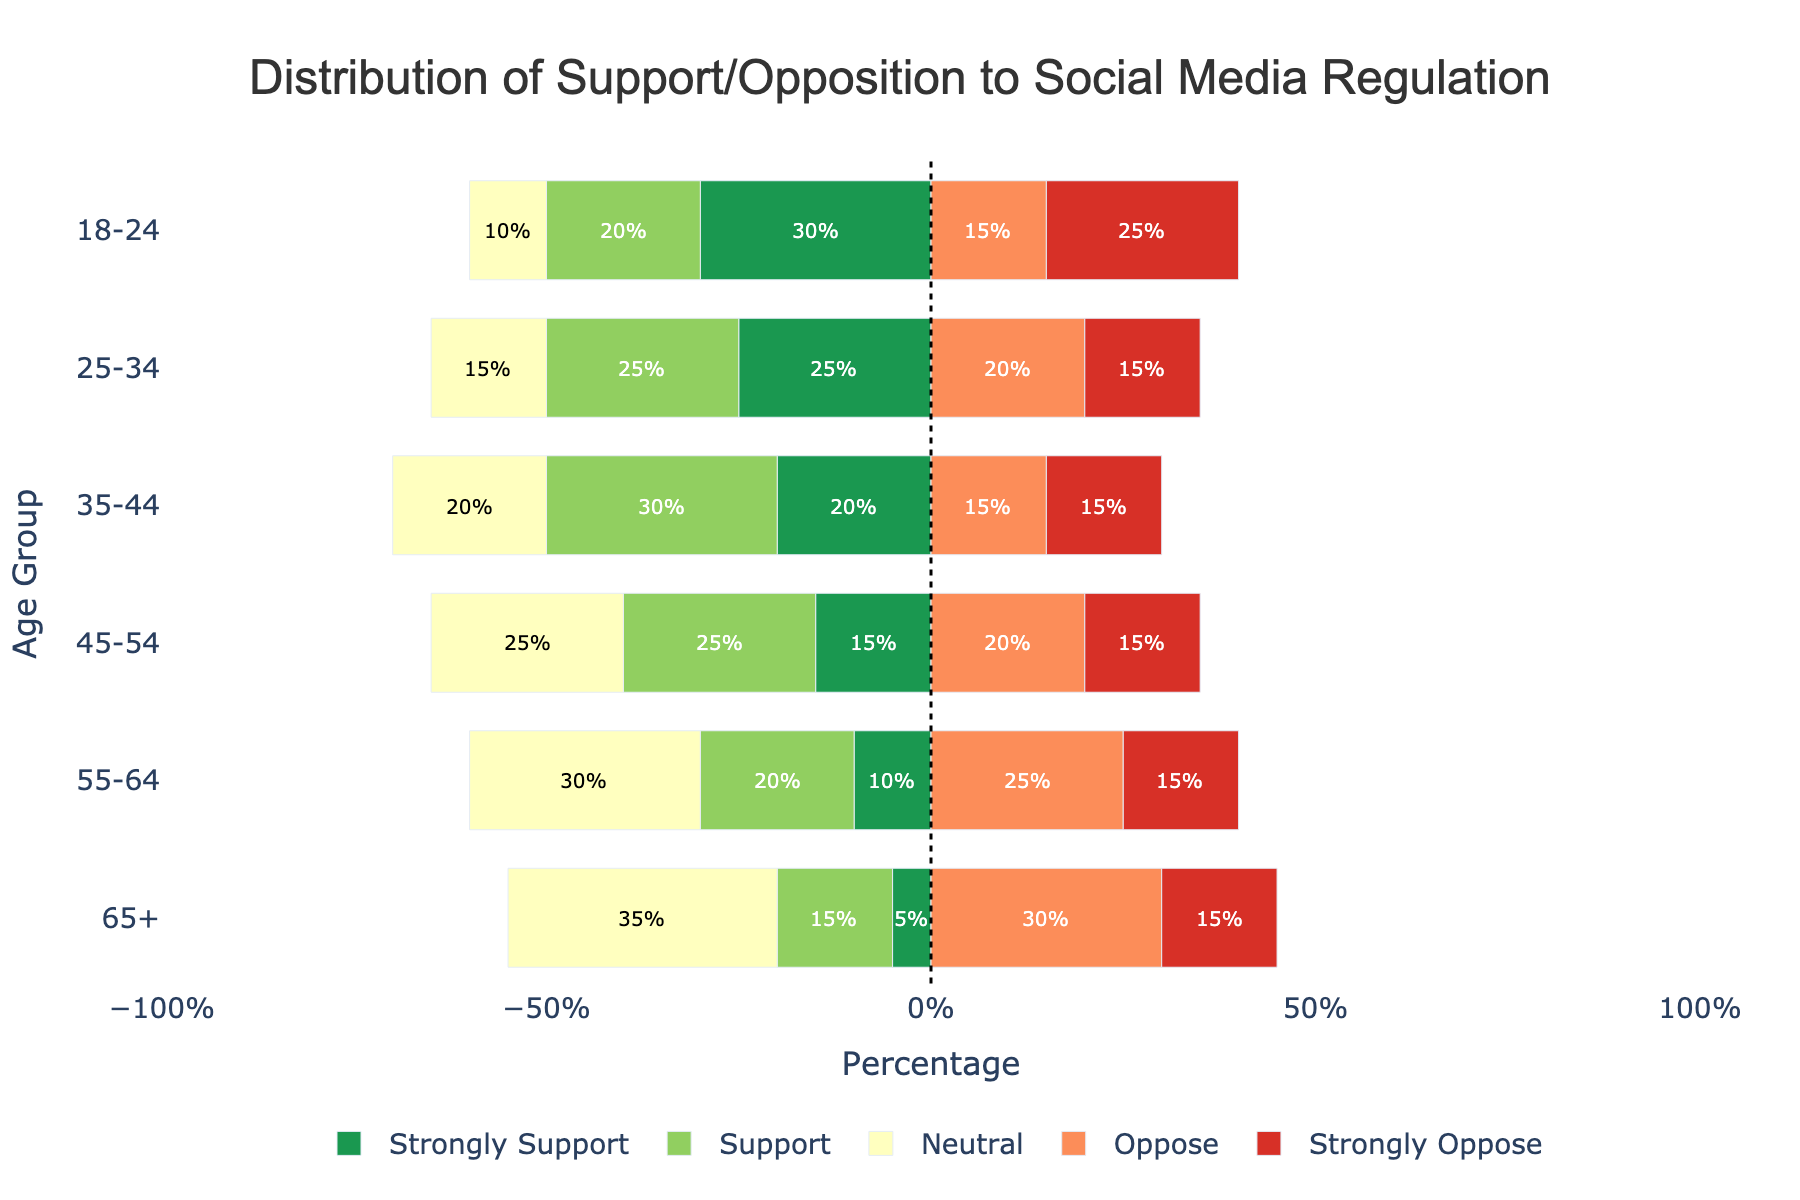What is the percentage of people aged 18-24 who support social media regulation (combining 'Strongly Support' and 'Support')? The percentage of people aged 18-24 who 'Strongly Support' is 30% and those who 'Support' are 20%. Adding these together: 30% + 20% = 50%
Answer: 50% Which age group has the highest percentage of people who are neutral about social media regulation? To determine the age group with the highest percentage of neutral respondents, compare the neutral percentages across all age groups. The percentages are: 10% (18-24), 15% (25-34), 20% (35-44), 25% (45-54), 30% (55-64), and 35% (65+). The highest is 35% for the 65+ age group.
Answer: 65+ Which age group shows the greatest opposition (combining 'Oppose' and 'Strongly Oppose') to social media regulation? For each age group, combine the percentages for 'Oppose' and 'Strongly Oppose'. The sums are: 15%+25% = 40% (18-24), 20%+15% = 35% (25-34), 15%+15% = 30% (35-44), 20%+15% = 35% (45-54), 25%+15% = 40% (55-64), and 30%+15% = 45% (65+). The highest opposition is 45% for the 65+ age group.
Answer: 65+ Which two age groups have equal percentages of strong opposition to social media regulation? Looking for equal values in the 'Strongly Oppose' column, we see: 25% (18-24), 15% (25-34), 15% (35-44), 15% (45-54), 15% (55-64), 15% (65+). The 25-34, 35-44, 45-54, 55-64, and 65+ age groups all have 15%. Any two of these groups have equal percentages.
Answer: 25-34 and 65+ What is the total percentage of people aged 45-54 who either strongly support or oppose social media regulation? For the 45-54 age group, 'Strongly Support' is 15% and 'Strongly Oppose' is also 15%. Adding these together: 15% + 15% = 30%
Answer: 30% Among the age groups, which has the lowest support (combining 'Support' and 'Strongly Support') for social media regulation? Comparing the sums of 'Support' and 'Strongly Support' across age groups, we get: 50% (18-24), 50% (25-34), 50% (35-44), 40% (45-54), 30% (55-64), and 20% (65+). The lowest support is 20% for the 65+ age group.
Answer: 65+ What is the difference in the percentage of people who strongly oppose social media regulation between the 18-24 and 25-34 age groups? The 'Strongly Oppose' percentage for the age group 18-24 is 25% and for 25-34 it is 15%. The difference is: 25% - 15% = 10%
Answer: 10% How does the percentage of neutral responses change as the age group increases? Observing the 'Neutral' percentages, we see: 10% (18-24), 15% (25-34), 20% (35-44), 25% (45-54), 30% (55-64), and 35% (65+). The percentage of neutral responses increases by 5% with each successive age group.
Answer: Increases 